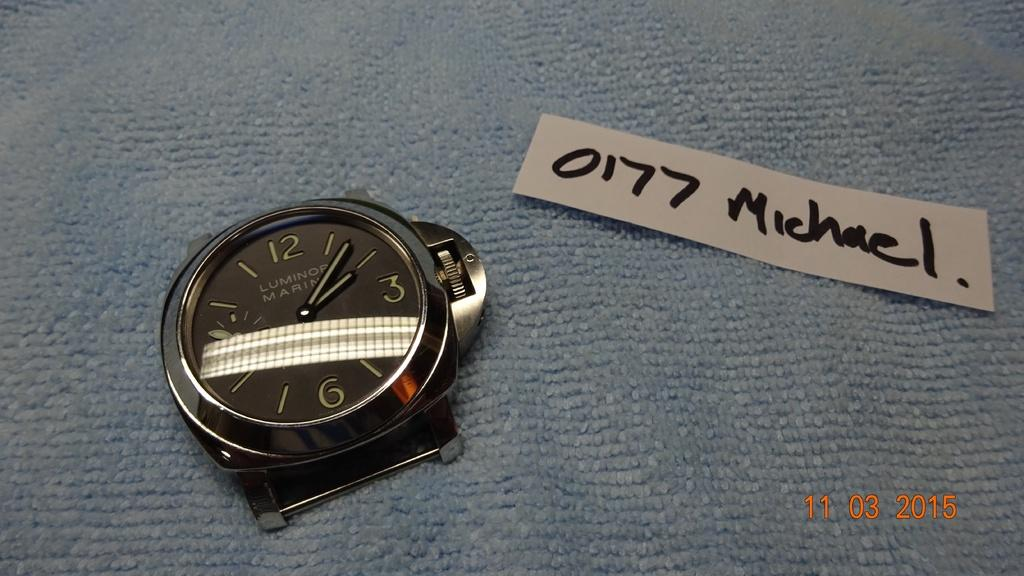<image>
Create a compact narrative representing the image presented. A scrap of paper, next to a watch body, reads 0177 michael. 